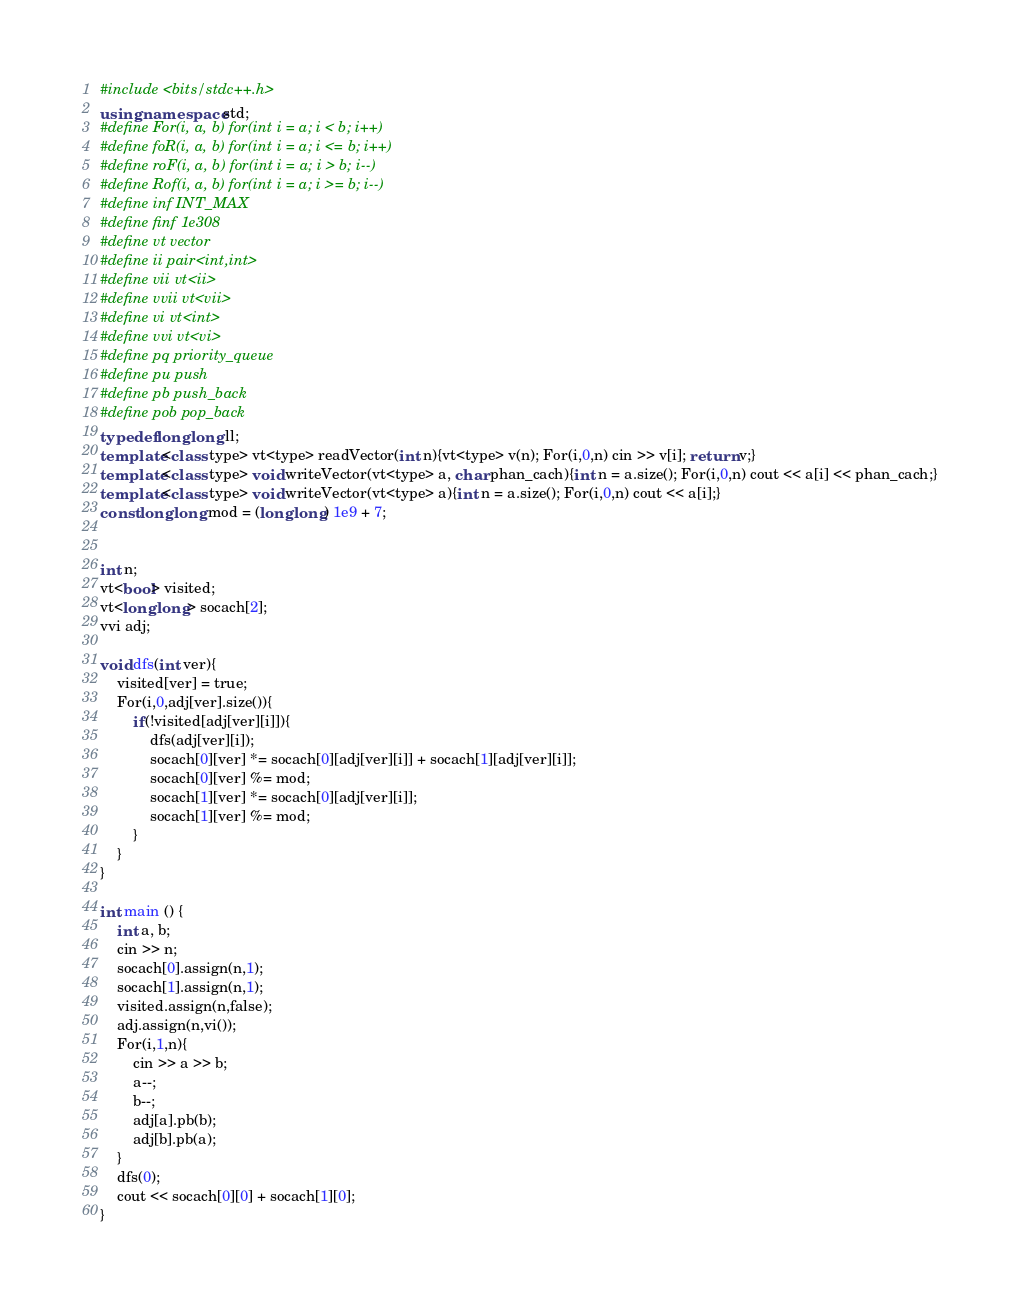Convert code to text. <code><loc_0><loc_0><loc_500><loc_500><_C++_>#include <bits/stdc++.h>
using namespace std;
#define For(i, a, b) for(int i = a; i < b; i++)
#define foR(i, a, b) for(int i = a; i <= b; i++)
#define roF(i, a, b) for(int i = a; i > b; i--)
#define Rof(i, a, b) for(int i = a; i >= b; i--)
#define inf INT_MAX
#define finf 1e308
#define vt vector
#define ii pair<int,int>
#define vii vt<ii>
#define vvii vt<vii>
#define vi vt<int>
#define vvi vt<vi>
#define pq priority_queue
#define pu push
#define pb push_back
#define pob pop_back
typedef long long ll;
template<class type> vt<type> readVector(int n){vt<type> v(n); For(i,0,n) cin >> v[i]; return v;}
template<class type> void writeVector(vt<type> a, char phan_cach){int n = a.size(); For(i,0,n) cout << a[i] << phan_cach;}
template<class type> void writeVector(vt<type> a){int n = a.size(); For(i,0,n) cout << a[i];}
const long long mod = (long long) 1e9 + 7;


int n;
vt<bool> visited;
vt<long long> socach[2];
vvi adj;

void dfs(int ver){
	visited[ver] = true;
	For(i,0,adj[ver].size()){
		if(!visited[adj[ver][i]]){
			dfs(adj[ver][i]);
			socach[0][ver] *= socach[0][adj[ver][i]] + socach[1][adj[ver][i]];
			socach[0][ver] %= mod;
			socach[1][ver] *= socach[0][adj[ver][i]];
			socach[1][ver] %= mod;
		}
	}
}

int main () {
	int a, b;
	cin >> n;
	socach[0].assign(n,1);
	socach[1].assign(n,1);
	visited.assign(n,false);
	adj.assign(n,vi());
	For(i,1,n){
		cin >> a >> b;
		a--;
		b--;
		adj[a].pb(b);
		adj[b].pb(a);
	}
	dfs(0);
	cout << socach[0][0] + socach[1][0];
}

</code> 